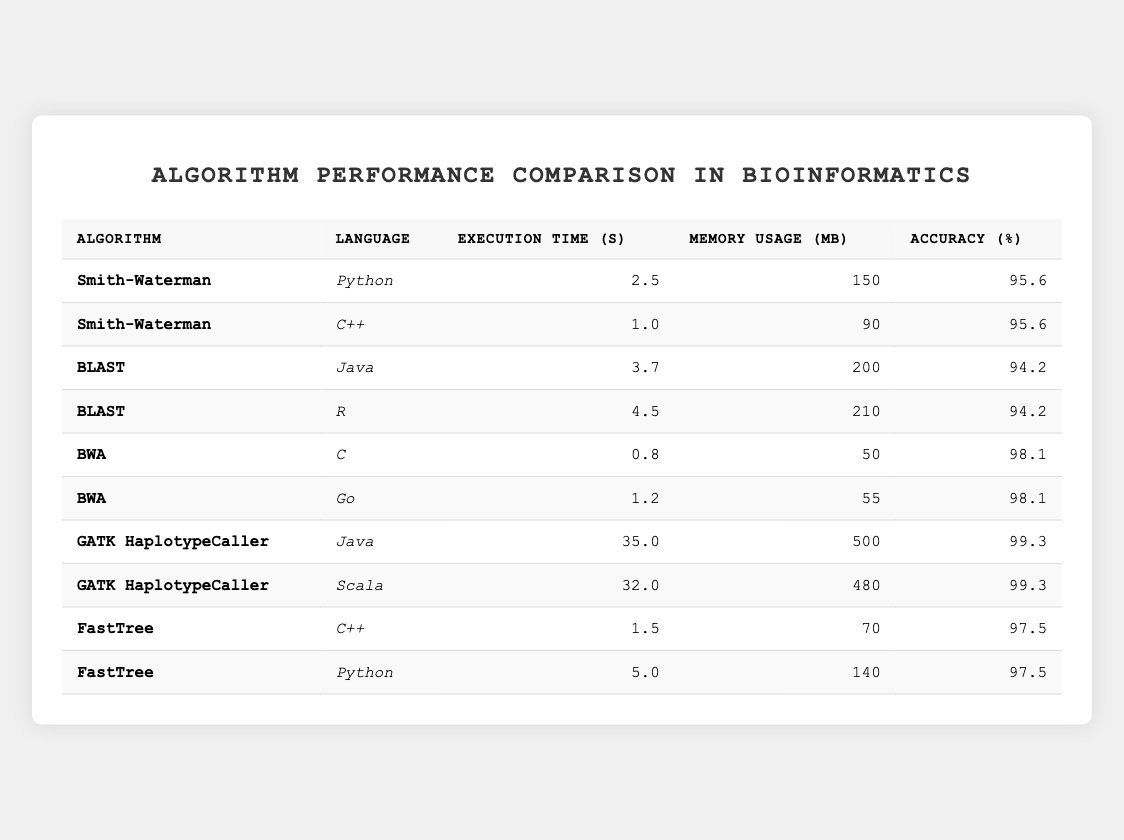What is the execution time of the Smith-Waterman algorithm in Python? The execution time for the Smith-Waterman algorithm listed under the Python programming language is directly visible in the table, which states it is 2.5 seconds.
Answer: 2.5 seconds Which algorithm has the highest accuracy percentage? By examining the accuracy percentages in the table, the BWA algorithm has the highest value at 98.1%, without comparison from others, since multiple algorithms have lower values.
Answer: BWA What is the memory usage for the GATK HaplotypeCaller algorithm in Java? The table indicates that the memory usage for the GATK HaplotypeCaller algorithm when implemented in Java is 500 megabytes.
Answer: 500 megabytes Which programming language has the lowest execution time across all algorithms? By comparing the execution times of all languages present in the table, C shows the lowest execution time of 0.8 seconds for the BWA algorithm.
Answer: C How much faster is the Smith-Waterman algorithm in C++ compared to Python? The execution time for Smith-Waterman in C++ is 1.0 seconds, and in Python, it is 2.5 seconds. Therefore, to find how much faster, subtract 1.0 from 2.5: 2.5 - 1.0 = 1.5 seconds.
Answer: 1.5 seconds Is the accuracy of the BWA algorithm the same in C and Go? The table shows that the accuracy for the BWA algorithm in both C and Go is 98.1%, meaning they are indeed the same.
Answer: Yes What are the average execution times for all algorithms listed in Python? To find the average, add the execution times for the two Python implementations (2.5 seconds for Smith-Waterman and 5.0 seconds for FastTree) which equals 7.5 seconds. Dividing by 2 gives an average of 3.75 seconds.
Answer: 3.75 seconds If we want to assess the overall memory usage of Java versus Scala for the GATK HaplotypeCaller, how do they compare? The memory usage for Java is 500 megabytes, while for Scala it is 480 megabytes. This means Java uses 20 megabytes more.
Answer: Java uses 20 megabytes more How much total memory is used by the algorithms implemented in C++? From the table, the memory usage amounts for algorithms implemented in C++ are 90 megabytes (Smith-Waterman) and 70 megabytes (FastTree). Adding these gives us a total of 160 megabytes used.
Answer: 160 megabytes What percentage of accuracy does the BLAST algorithm achieve in both Java and R? The accuracy for both implementations of the BLAST algorithm is listed as 94.2%, confirming they achieve the same accuracy in both programming languages.
Answer: 94.2% In terms of execution time, how do the GATK HaplotypeCaller algorithms in Java and Scala compare? The GATK HaplotypeCaller in Java takes 35.0 seconds while in Scala it takes 32.0 seconds. The difference in execution times is 35.0 - 32.0 = 3.0 seconds, indicating that Scala is faster by this amount.
Answer: Scala is faster by 3.0 seconds 